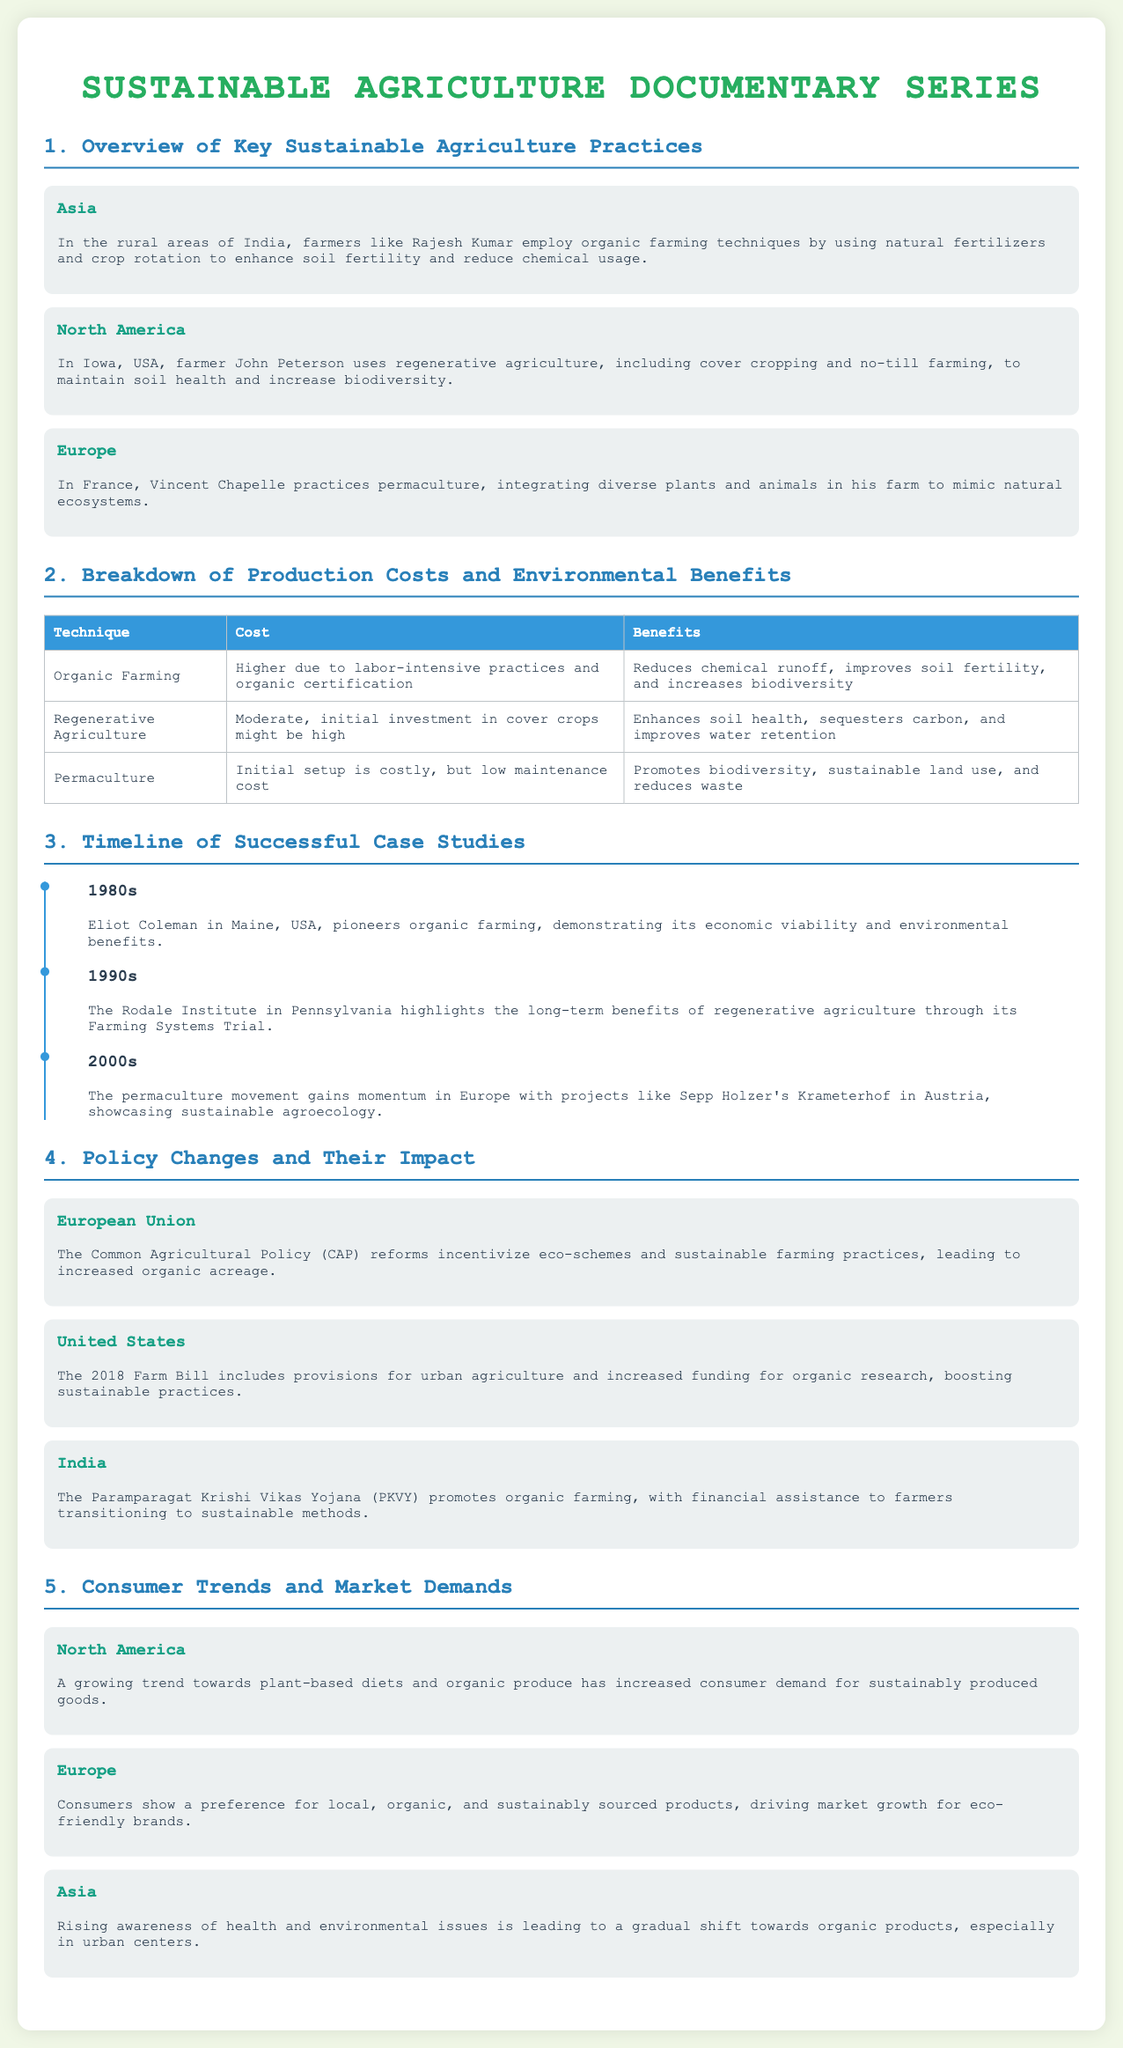what sustainable farming practice does Rajesh Kumar use in India? The document states that Rajesh Kumar employs organic farming techniques using natural fertilizers and crop rotation.
Answer: organic farming what type of agriculture is practiced by John Peterson in Iowa, USA? The document mentions that John Peterson uses regenerative agriculture, including cover cropping and no-till farming.
Answer: regenerative agriculture what decade did Eliot Coleman pioneer organic farming? The timeline in the document indicates that Eliot Coleman pioneered organic farming in the 1980s.
Answer: 1980s what is the initial cost type for permaculture according to the document? According to the table, the initial setup for permaculture is said to be costly, but it has low maintenance cost.
Answer: costly how did the European Union's Common Agricultural Policy (CAP) reforms affect organic farming? The document states that the CAP reforms incentivize eco-schemes and sustainable farming practices, leading to increased organic acreage.
Answer: increased organic acreage which country has the Paramparagat Krishi Vikas Yojana (PKVY) promoting organic farming? The document mentions that the Paramparagat Krishi Vikas Yojana (PKVY) promotes organic farming in India.
Answer: India what trends are driving market growth for sustainable products in Europe? The document indicates that consumers show a preference for local, organic, and sustainably sourced products.
Answer: local, organic, and sustainably sourced products how does regenerative agriculture affect soil? The document states that regenerative agriculture enhances soil health and sequesters carbon, improving water retention.
Answer: enhances soil health what is the main focus of the documentary series? The title of the document reveals that the focus is on sustainable agriculture practices across various regions.
Answer: sustainable agriculture practices 